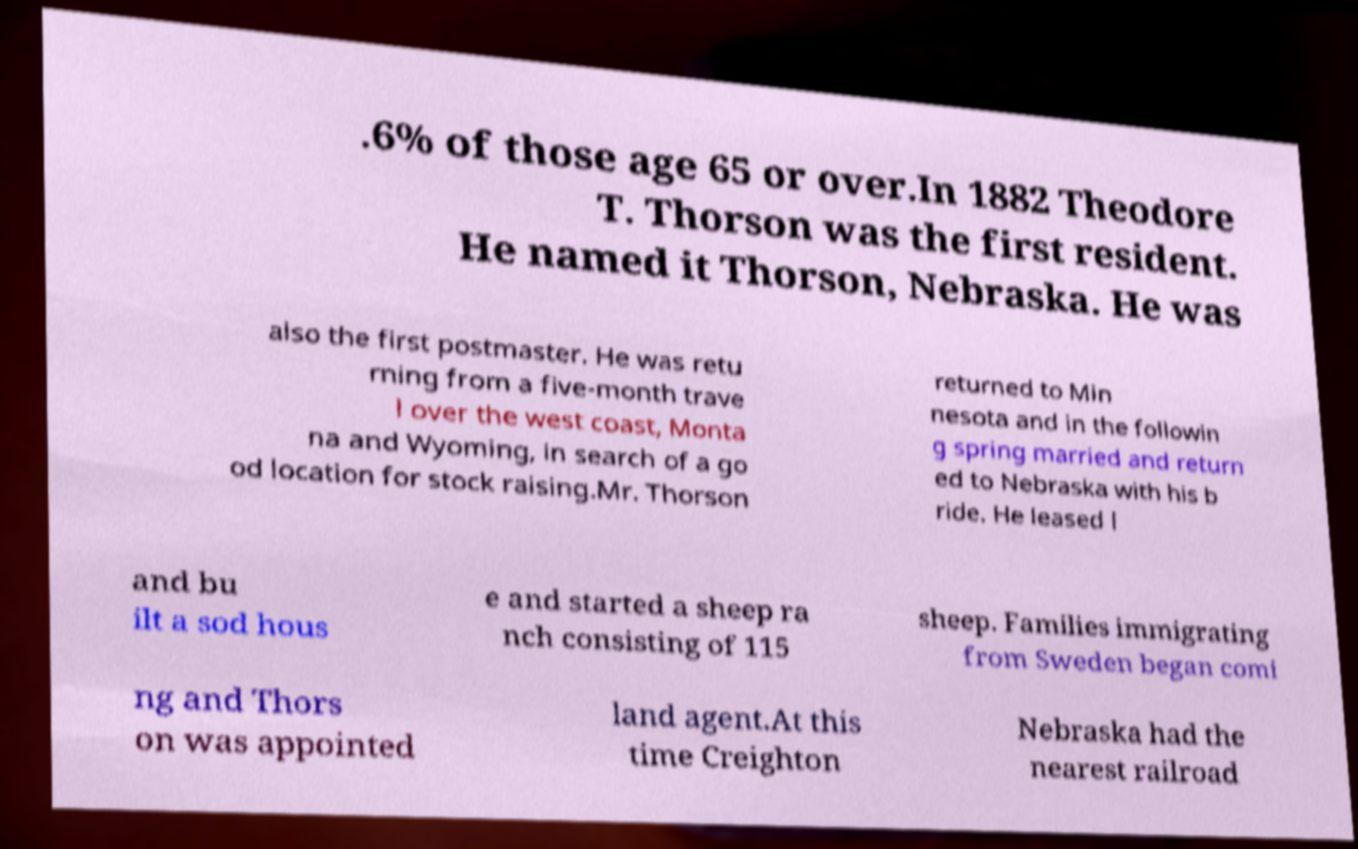Can you read and provide the text displayed in the image?This photo seems to have some interesting text. Can you extract and type it out for me? .6% of those age 65 or over.In 1882 Theodore T. Thorson was the first resident. He named it Thorson, Nebraska. He was also the first postmaster. He was retu rning from a five-month trave l over the west coast, Monta na and Wyoming, in search of a go od location for stock raising.Mr. Thorson returned to Min nesota and in the followin g spring married and return ed to Nebraska with his b ride. He leased l and bu ilt a sod hous e and started a sheep ra nch consisting of 115 sheep. Families immigrating from Sweden began comi ng and Thors on was appointed land agent.At this time Creighton Nebraska had the nearest railroad 